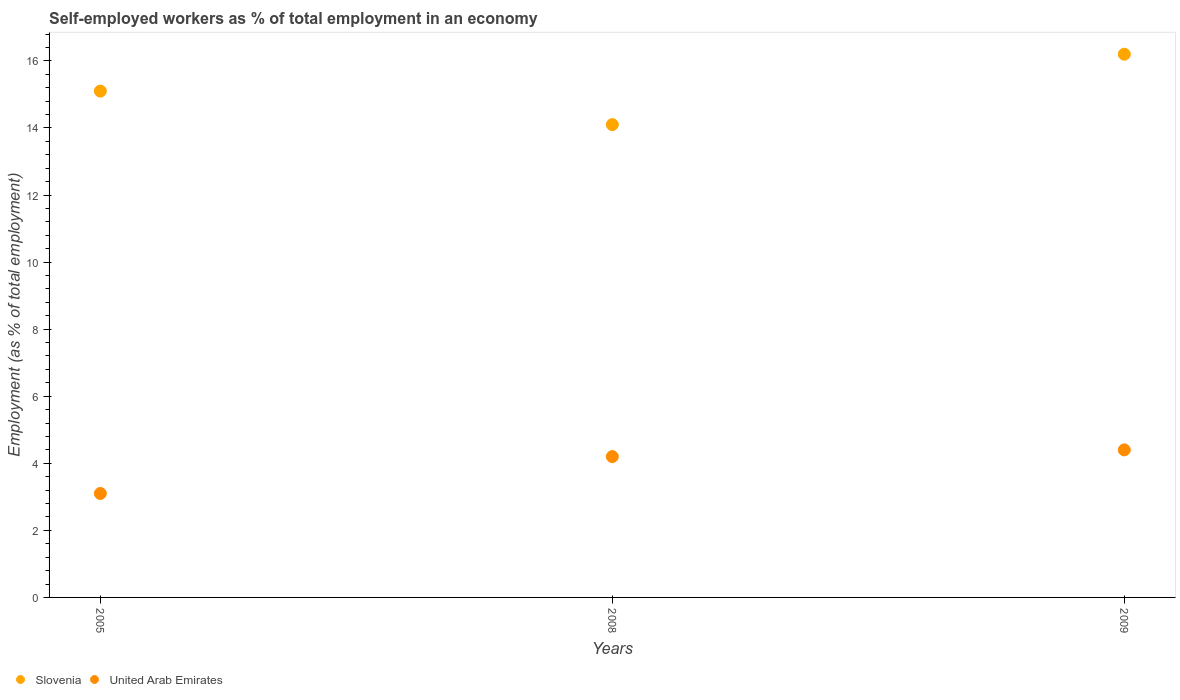Is the number of dotlines equal to the number of legend labels?
Ensure brevity in your answer.  Yes. What is the percentage of self-employed workers in United Arab Emirates in 2009?
Ensure brevity in your answer.  4.4. Across all years, what is the maximum percentage of self-employed workers in Slovenia?
Keep it short and to the point. 16.2. Across all years, what is the minimum percentage of self-employed workers in Slovenia?
Your answer should be compact. 14.1. In which year was the percentage of self-employed workers in Slovenia maximum?
Make the answer very short. 2009. In which year was the percentage of self-employed workers in Slovenia minimum?
Your response must be concise. 2008. What is the total percentage of self-employed workers in United Arab Emirates in the graph?
Your response must be concise. 11.7. What is the difference between the percentage of self-employed workers in Slovenia in 2005 and that in 2008?
Ensure brevity in your answer.  1. What is the difference between the percentage of self-employed workers in Slovenia in 2005 and the percentage of self-employed workers in United Arab Emirates in 2008?
Give a very brief answer. 10.9. What is the average percentage of self-employed workers in United Arab Emirates per year?
Offer a terse response. 3.9. In the year 2008, what is the difference between the percentage of self-employed workers in United Arab Emirates and percentage of self-employed workers in Slovenia?
Provide a succinct answer. -9.9. In how many years, is the percentage of self-employed workers in United Arab Emirates greater than 2 %?
Make the answer very short. 3. What is the ratio of the percentage of self-employed workers in Slovenia in 2005 to that in 2009?
Offer a terse response. 0.93. Is the percentage of self-employed workers in United Arab Emirates in 2008 less than that in 2009?
Give a very brief answer. Yes. What is the difference between the highest and the second highest percentage of self-employed workers in United Arab Emirates?
Provide a succinct answer. 0.2. What is the difference between the highest and the lowest percentage of self-employed workers in Slovenia?
Keep it short and to the point. 2.1. Is the sum of the percentage of self-employed workers in Slovenia in 2005 and 2008 greater than the maximum percentage of self-employed workers in United Arab Emirates across all years?
Give a very brief answer. Yes. Does the percentage of self-employed workers in United Arab Emirates monotonically increase over the years?
Ensure brevity in your answer.  Yes. Is the percentage of self-employed workers in Slovenia strictly greater than the percentage of self-employed workers in United Arab Emirates over the years?
Your answer should be very brief. Yes. Is the percentage of self-employed workers in United Arab Emirates strictly less than the percentage of self-employed workers in Slovenia over the years?
Keep it short and to the point. Yes. How many dotlines are there?
Make the answer very short. 2. How many years are there in the graph?
Ensure brevity in your answer.  3. Are the values on the major ticks of Y-axis written in scientific E-notation?
Offer a terse response. No. Does the graph contain grids?
Your response must be concise. No. Where does the legend appear in the graph?
Ensure brevity in your answer.  Bottom left. How are the legend labels stacked?
Provide a succinct answer. Horizontal. What is the title of the graph?
Your response must be concise. Self-employed workers as % of total employment in an economy. What is the label or title of the Y-axis?
Ensure brevity in your answer.  Employment (as % of total employment). What is the Employment (as % of total employment) of Slovenia in 2005?
Your response must be concise. 15.1. What is the Employment (as % of total employment) of United Arab Emirates in 2005?
Your response must be concise. 3.1. What is the Employment (as % of total employment) of Slovenia in 2008?
Provide a succinct answer. 14.1. What is the Employment (as % of total employment) in United Arab Emirates in 2008?
Make the answer very short. 4.2. What is the Employment (as % of total employment) in Slovenia in 2009?
Offer a very short reply. 16.2. What is the Employment (as % of total employment) in United Arab Emirates in 2009?
Keep it short and to the point. 4.4. Across all years, what is the maximum Employment (as % of total employment) in Slovenia?
Offer a terse response. 16.2. Across all years, what is the maximum Employment (as % of total employment) in United Arab Emirates?
Keep it short and to the point. 4.4. Across all years, what is the minimum Employment (as % of total employment) of Slovenia?
Provide a short and direct response. 14.1. Across all years, what is the minimum Employment (as % of total employment) in United Arab Emirates?
Offer a terse response. 3.1. What is the total Employment (as % of total employment) of Slovenia in the graph?
Provide a succinct answer. 45.4. What is the difference between the Employment (as % of total employment) of Slovenia in 2005 and that in 2008?
Your answer should be very brief. 1. What is the difference between the Employment (as % of total employment) in United Arab Emirates in 2005 and that in 2008?
Offer a terse response. -1.1. What is the difference between the Employment (as % of total employment) of Slovenia in 2005 and that in 2009?
Provide a succinct answer. -1.1. What is the difference between the Employment (as % of total employment) of Slovenia in 2008 and that in 2009?
Your answer should be compact. -2.1. What is the difference between the Employment (as % of total employment) in United Arab Emirates in 2008 and that in 2009?
Provide a succinct answer. -0.2. What is the difference between the Employment (as % of total employment) in Slovenia in 2005 and the Employment (as % of total employment) in United Arab Emirates in 2008?
Provide a succinct answer. 10.9. What is the difference between the Employment (as % of total employment) of Slovenia in 2008 and the Employment (as % of total employment) of United Arab Emirates in 2009?
Your response must be concise. 9.7. What is the average Employment (as % of total employment) of Slovenia per year?
Your response must be concise. 15.13. What is the average Employment (as % of total employment) of United Arab Emirates per year?
Make the answer very short. 3.9. In the year 2005, what is the difference between the Employment (as % of total employment) of Slovenia and Employment (as % of total employment) of United Arab Emirates?
Give a very brief answer. 12. In the year 2008, what is the difference between the Employment (as % of total employment) of Slovenia and Employment (as % of total employment) of United Arab Emirates?
Your answer should be compact. 9.9. In the year 2009, what is the difference between the Employment (as % of total employment) in Slovenia and Employment (as % of total employment) in United Arab Emirates?
Provide a short and direct response. 11.8. What is the ratio of the Employment (as % of total employment) of Slovenia in 2005 to that in 2008?
Keep it short and to the point. 1.07. What is the ratio of the Employment (as % of total employment) of United Arab Emirates in 2005 to that in 2008?
Offer a very short reply. 0.74. What is the ratio of the Employment (as % of total employment) of Slovenia in 2005 to that in 2009?
Make the answer very short. 0.93. What is the ratio of the Employment (as % of total employment) of United Arab Emirates in 2005 to that in 2009?
Offer a terse response. 0.7. What is the ratio of the Employment (as % of total employment) of Slovenia in 2008 to that in 2009?
Give a very brief answer. 0.87. What is the ratio of the Employment (as % of total employment) in United Arab Emirates in 2008 to that in 2009?
Give a very brief answer. 0.95. What is the difference between the highest and the second highest Employment (as % of total employment) in Slovenia?
Your response must be concise. 1.1. What is the difference between the highest and the second highest Employment (as % of total employment) in United Arab Emirates?
Your answer should be very brief. 0.2. What is the difference between the highest and the lowest Employment (as % of total employment) of Slovenia?
Make the answer very short. 2.1. What is the difference between the highest and the lowest Employment (as % of total employment) of United Arab Emirates?
Ensure brevity in your answer.  1.3. 